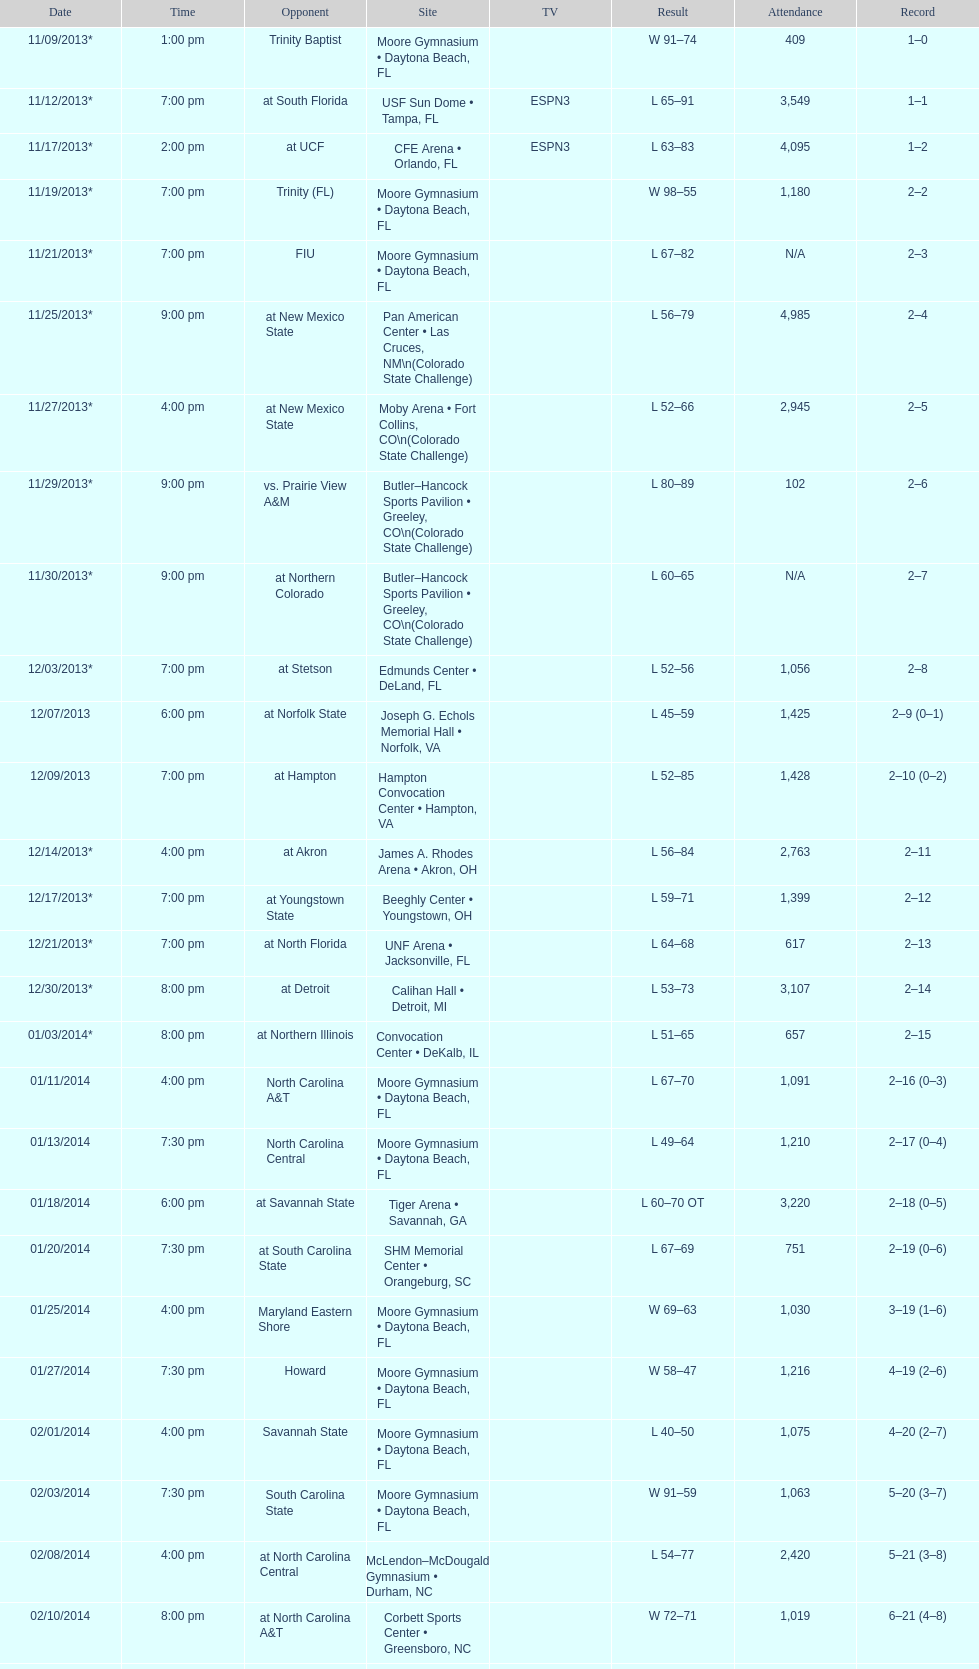Which game was later at night, fiu or northern colorado? Northern Colorado. 